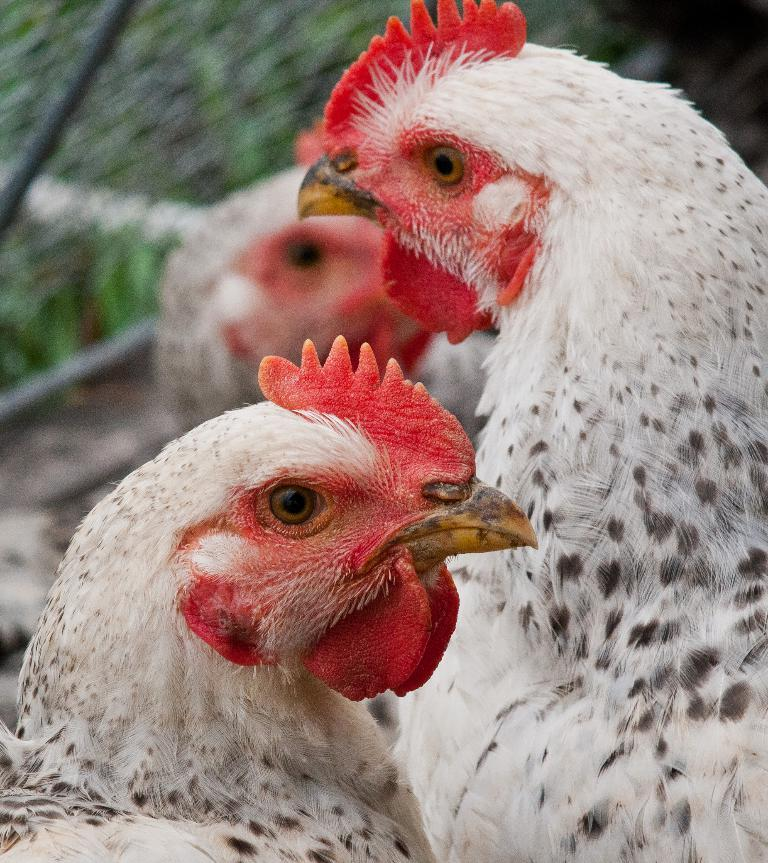What animals are present in the image? There are two hens in the image. What color are the hens? The hens are white in color. Can you describe the background of the image? The background of the image is blurry. How many children are holding the locket in the image? There is no locket or children present in the image. What is the limit of the hens' ability to fly in the image? The image does not provide information about the hens' ability to fly, nor does it establish a limit for their flight. 